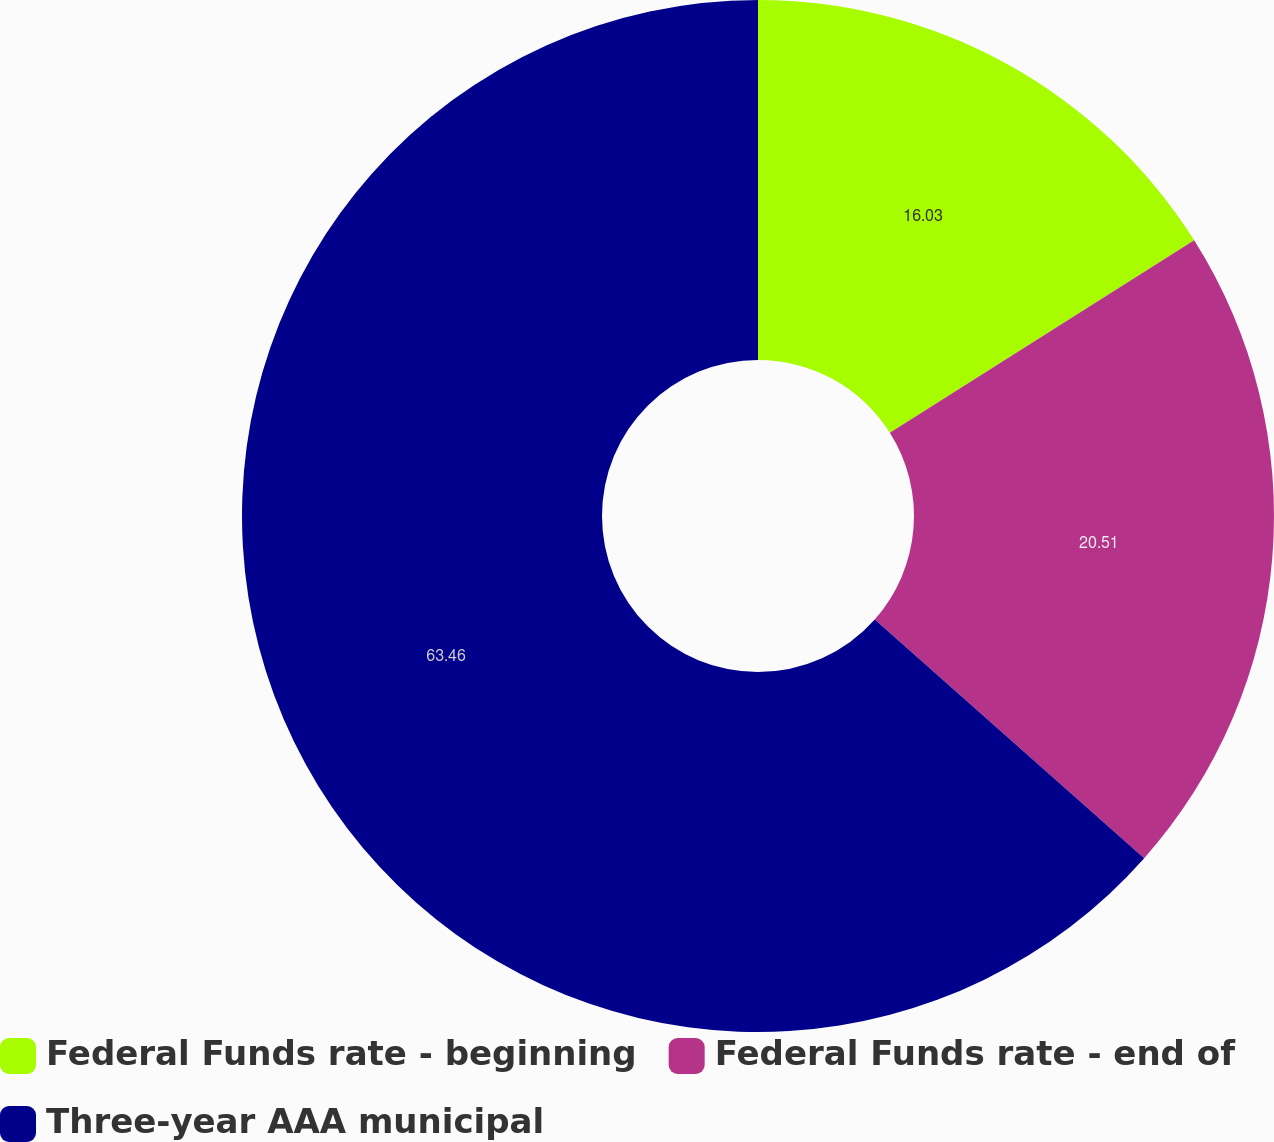<chart> <loc_0><loc_0><loc_500><loc_500><pie_chart><fcel>Federal Funds rate - beginning<fcel>Federal Funds rate - end of<fcel>Three-year AAA municipal<nl><fcel>16.03%<fcel>20.51%<fcel>63.46%<nl></chart> 